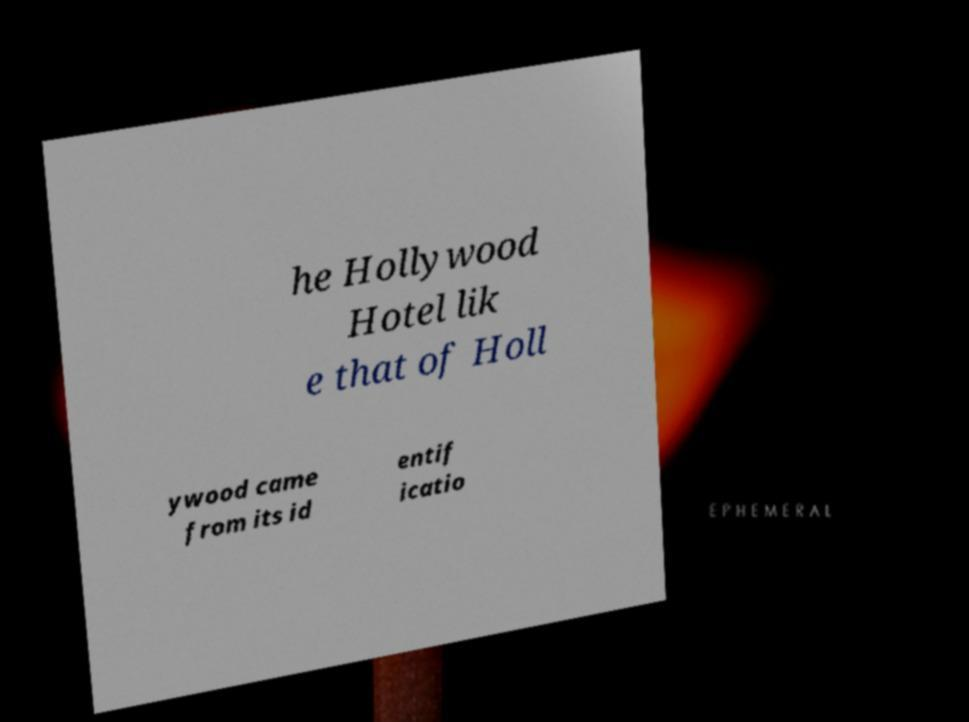Can you accurately transcribe the text from the provided image for me? he Hollywood Hotel lik e that of Holl ywood came from its id entif icatio 